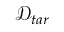Convert formula to latex. <formula><loc_0><loc_0><loc_500><loc_500>\mathcal { D } _ { t a r }</formula> 